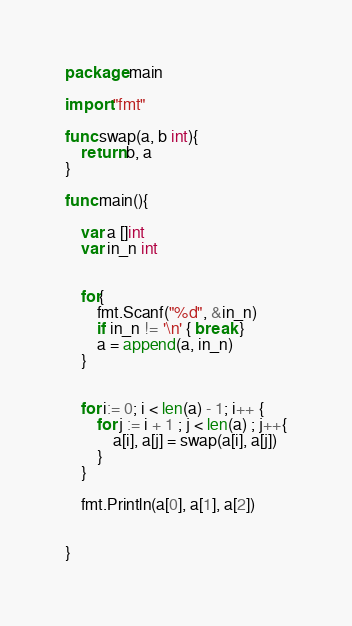<code> <loc_0><loc_0><loc_500><loc_500><_Go_>package main

import "fmt"

func swap(a, b int){
    return b, a
}

func main(){

    var a []int
    var in_n int

    
    for{
        fmt.Scanf("%d", &in_n) 
        if in_n != '\n' { break } 
        a = append(a, in_n)
    }

 
    for i:= 0; i < len(a) - 1; i++ {
        for j := i + 1 ; j < len(a) ; j++{
            a[i], a[j] = swap(a[i], a[j])
        }
    } 
    
    fmt.Println(a[0], a[1], a[2])


}
</code> 